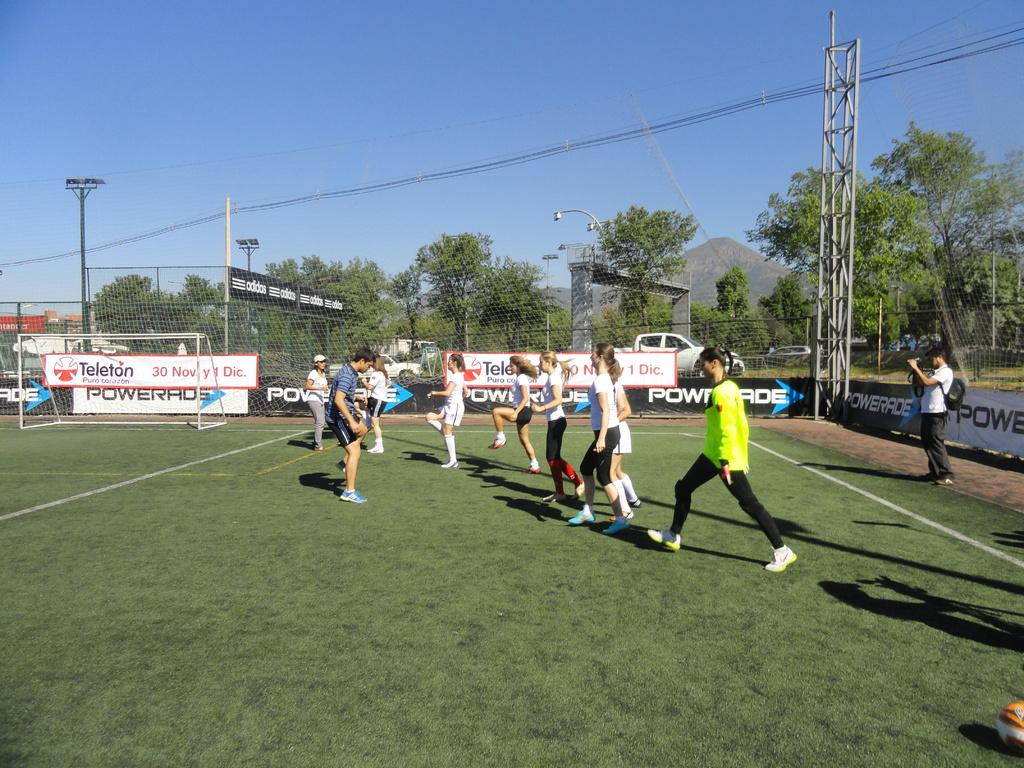<image>
Offer a succinct explanation of the picture presented. A field with billboards from Powerade and Teleton has many girls stretching on it. 